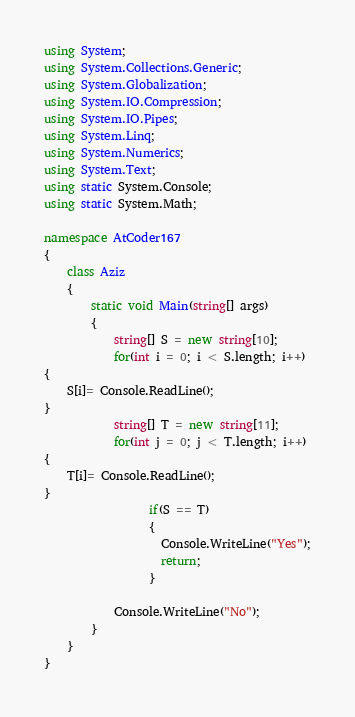<code> <loc_0><loc_0><loc_500><loc_500><_C#_>using System;
using System.Collections.Generic;
using System.Globalization;
using System.IO.Compression;
using System.IO.Pipes;
using System.Linq;
using System.Numerics;
using System.Text;
using static System.Console;
using static System.Math;
 
namespace AtCoder167
{
    class Aziz
    {
        static void Main(string[] args)
        {
            string[] S = new string[10];
            for(int i = 0; i < S.length; i++)
{
    S[i]= Console.ReadLine();
}
            string[] T = new string[11];
            for(int j = 0; j < T.length; i++)
{
    T[i]= Console.ReadLine();
}
                  if(S == T)
                  {
                    Console.WriteLine("Yes");
                    return;
                  }      
            
            Console.WriteLine("No");
        }
    }
}
</code> 